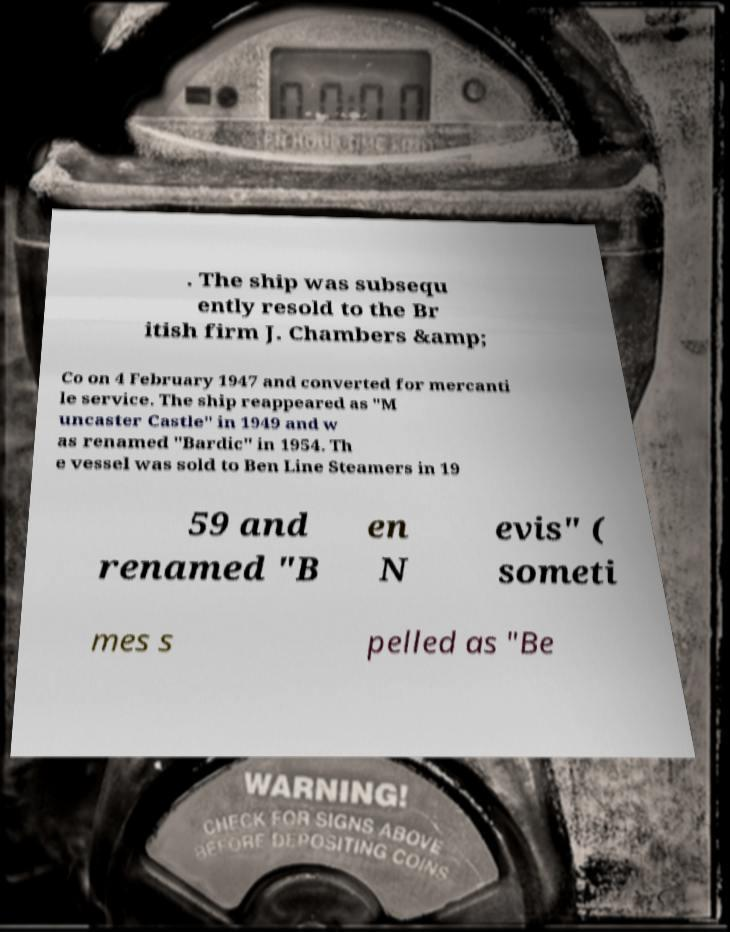For documentation purposes, I need the text within this image transcribed. Could you provide that? . The ship was subsequ ently resold to the Br itish firm J. Chambers &amp; Co on 4 February 1947 and converted for mercanti le service. The ship reappeared as "M uncaster Castle" in 1949 and w as renamed "Bardic" in 1954. Th e vessel was sold to Ben Line Steamers in 19 59 and renamed "B en N evis" ( someti mes s pelled as "Be 